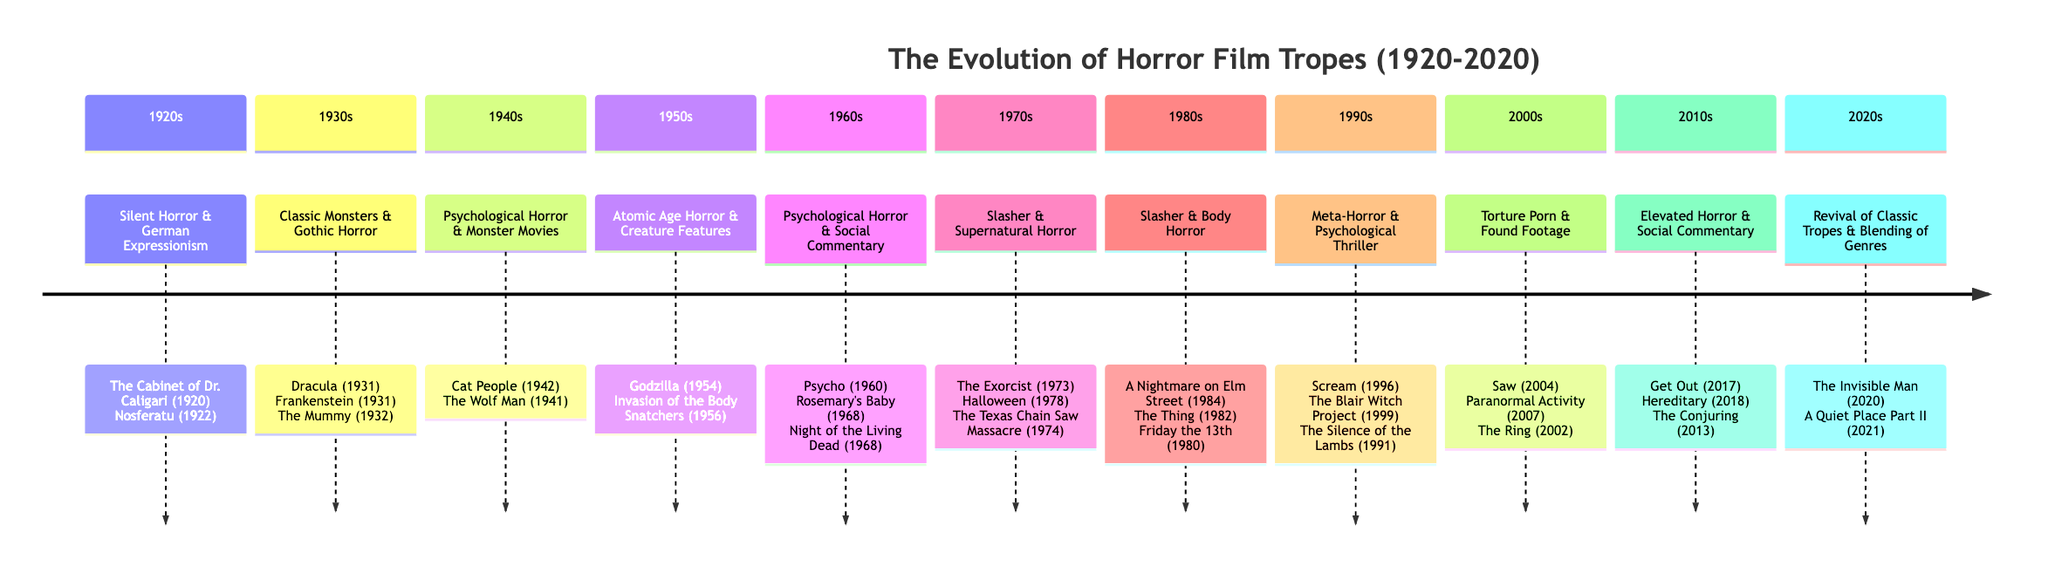What key tropes emerged in the 1980s? The diagram shows that the key tropes for the 1980s are "Slasher" and "Body Horror." This information can be found directly in the "1980s" section of the timeline.
Answer: Slasher, Body Horror Which decade featured the major release "Halloween"? By looking through the timeline, "Halloween" is listed under the "1970s" section, specifically associated with the tropes of "Slasher" and "Supernatural Horror."
Answer: 1970s How many major releases are listed for the 1960s? In the "1960s" section of the timeline, there are three major releases: "Psycho," "Rosemary's Baby," and "Night of the Living Dead." This can be counted directly from that section.
Answer: 3 What trope is associated with "The Ring"? According to the timeline, "The Ring" is included in the "2000s" section, which is characterized by the tropes "Torture Porn" and "Found Footage." Therefore, the associated trope is "Found Footage."
Answer: Found Footage Which decades are characterized by the "Psychological Horror" trope? The "Psychological Horror" trope appears in the "1940s" and "1960s" sections of the timeline. Thus, both of these decades are associated with this trope.
Answer: 1940s, 1960s What major release was highlighted in the 2020s? The "2020s" section features major releases, including "The Invisible Man" and "A Quiet Place Part II." This information can be directly found in that section.
Answer: The Invisible Man, A Quiet Place Part II In which decade did "Scream" get released? Looking at the timeline, "Scream" is located in the "1990s" section. Therefore, that is the decade of its release.
Answer: 1990s How did the 2010s redefine horror film tropes? In the timeline, the "2010s" are described with the key tropes "Elevated Horror" and "Social Commentary." This signifies the shift in focusing on deeper themes compared to prior decades.
Answer: Elevated Horror, Social Commentary What trend is observed in the 2020s regarding horror film tropes? The timeline indicates the "2020s" feature a "Revival of Classic Tropes" and "Blending of Genres," indicating a mix of old and new styles in horror films.
Answer: Revival of Classic Tropes, Blending of Genres 